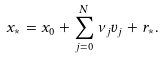Convert formula to latex. <formula><loc_0><loc_0><loc_500><loc_500>x _ { * } = x _ { 0 } + \sum _ { j = 0 } ^ { N } \nu _ { j } v _ { j } + r _ { * } .</formula> 